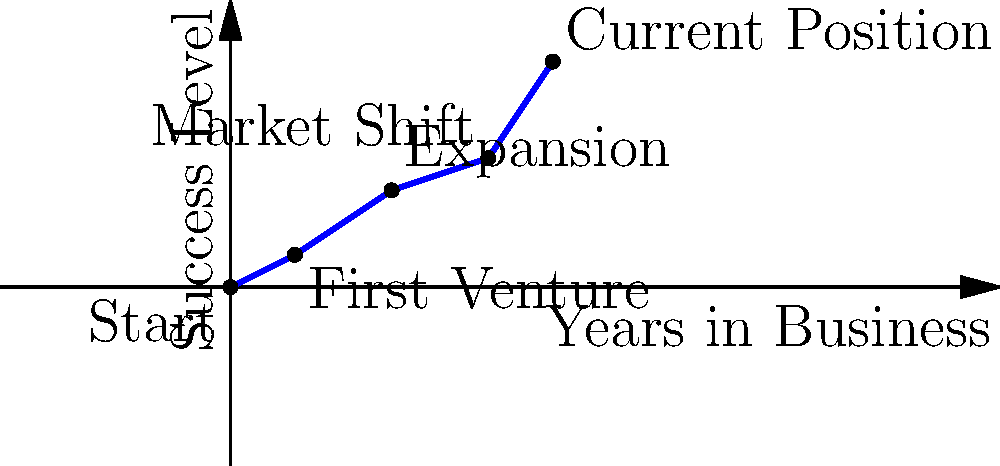As a close friend who has witnessed the businesswoman's career trajectory, you've plotted her key career moves on a coordinate system. The x-axis represents years in business, and the y-axis represents her success level. If her career moves are represented by the vector $\vec{v} = \langle 10, 7 \rangle$, what is the magnitude of her overall career progress vector? To find the magnitude of the businesswoman's career progress vector, we need to follow these steps:

1) The vector $\vec{v} = \langle 10, 7 \rangle$ represents her career progress from the starting point (0,0) to her current position (10,7) after 10 years in business.

2) The magnitude of a vector $\vec{v} = \langle a, b \rangle$ is given by the formula:

   $\|\vec{v}\| = \sqrt{a^2 + b^2}$

3) In this case, $a = 10$ and $b = 7$. Let's substitute these values:

   $\|\vec{v}\| = \sqrt{10^2 + 7^2}$

4) Simplify:
   $\|\vec{v}\| = \sqrt{100 + 49}$
   $\|\vec{v}\| = \sqrt{149}$

5) Calculate the square root:
   $\|\vec{v}\| \approx 12.21$

Therefore, the magnitude of her overall career progress vector is approximately 12.21 units.
Answer: $\sqrt{149} \approx 12.21$ 